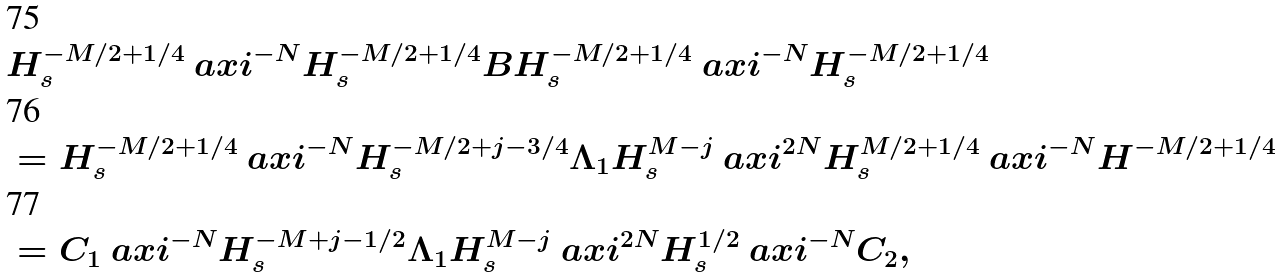Convert formula to latex. <formula><loc_0><loc_0><loc_500><loc_500>& H _ { s } ^ { - M / 2 + 1 / 4 } \ a x i ^ { - N } H _ { s } ^ { - M / 2 + 1 / 4 } B H _ { s } ^ { - M / 2 + 1 / 4 } \ a x i ^ { - N } H _ { s } ^ { - M / 2 + 1 / 4 } \\ & = H _ { s } ^ { - M / 2 + 1 / 4 } \ a x i ^ { - N } H _ { s } ^ { - M / 2 + j - 3 / 4 } \Lambda _ { 1 } H _ { s } ^ { M - j } \ a x i ^ { 2 N } H _ { s } ^ { M / 2 + 1 / 4 } \ a x i ^ { - N } H ^ { - M / 2 + 1 / 4 } \\ & = C _ { 1 } \ a x i ^ { - N } H _ { s } ^ { - M + j - 1 / 2 } \Lambda _ { 1 } H _ { s } ^ { M - j } \ a x i ^ { 2 N } H _ { s } ^ { 1 / 2 } \ a x i ^ { - N } C _ { 2 } ,</formula> 